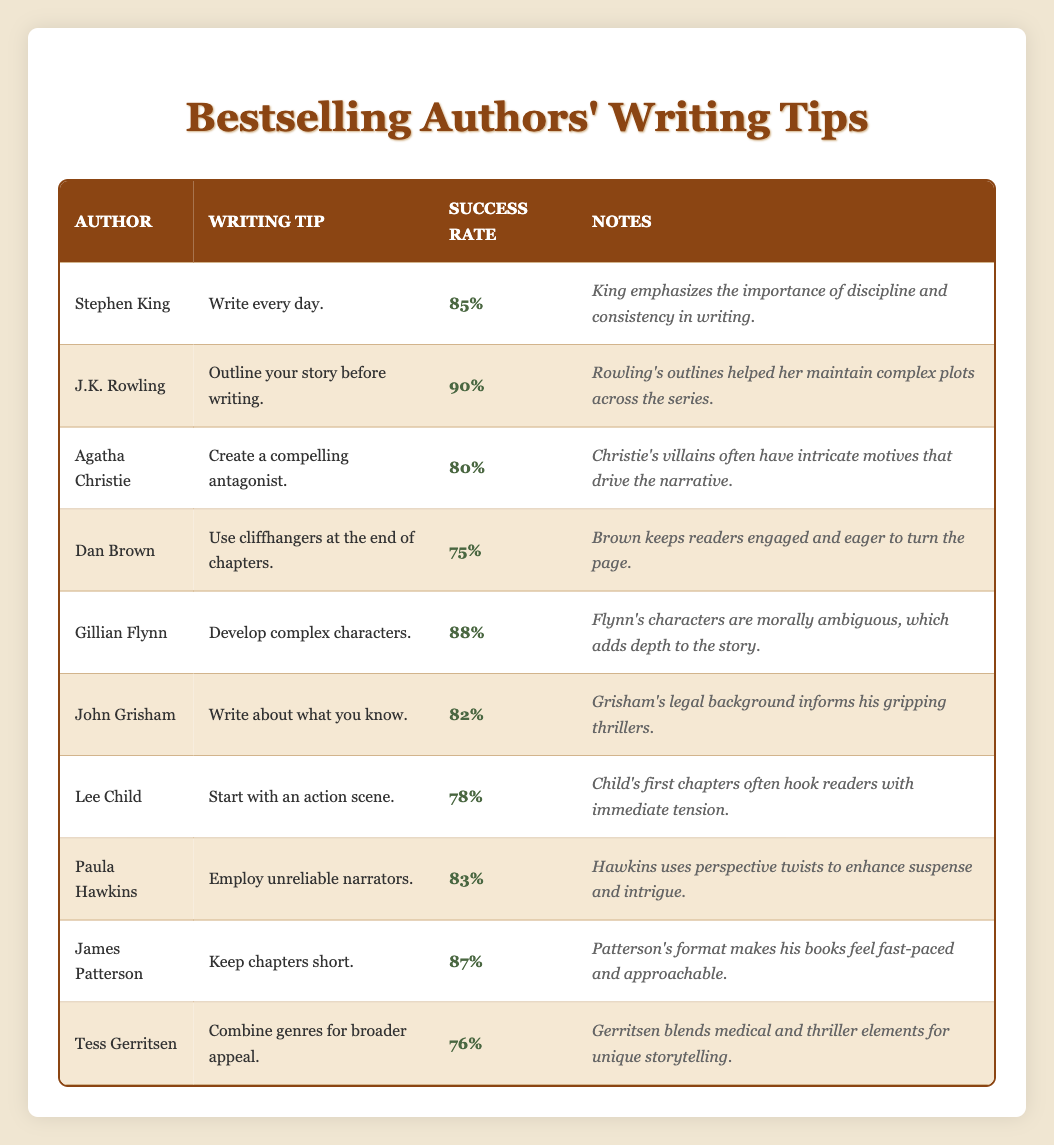What is the writing tip given by J.K. Rowling? J.K. Rowling's writing tip is found in the second row of the table. It states "Outline your story before writing."
Answer: Outline your story before writing Which author has the highest success rate? By checking the success rates listed, J.K. Rowling has the highest success rate at 90%.
Answer: J.K. Rowling What percentage of authors suggest using cliffhangers at the end of chapters? The table shows that Dan Brown suggests using cliffhangers, and his success rate is 75%.
Answer: 75% Is it true that Gillian Flynn recommends developing complex characters? The table lists Gillian Flynn's writing tip as "Develop complex characters," confirming the fact.
Answer: Yes What is the average success rate of authors recommending to write every day, outline a story, or develop complex characters? The authors recommending these tips are Stephen King, J.K. Rowling, and Gillian Flynn with success rates of 85%, 90%, and 88% respectively. The average is calculated as (85 + 90 + 88) / 3 = 87.67%.
Answer: 87.67% How many authors suggest using unreliable narrators? The table shows that only one author, Paula Hawkins, suggests using unreliable narrators.
Answer: One author What is the total success rate of authors who combine genres for broader appeal? Since only Tess Gerritsen suggests this tip, her success rate of 76% is the total for that category.
Answer: 76% Which author's approach involves keeping chapters short? The data shows that James Patterson recommends keeping chapters short, as indicated in his entry.
Answer: James Patterson Which writing tip is associated with the lowest success rate? Looking at the table, Dan Brown's tip of using cliffhangers has the lowest success rate of 75%.
Answer: Use cliffhangers at the end of chapters What are the success rates of authors who write about what they know compared to those who create compelling antagonists? John Grisham, who writes about what he knows, has a success rate of 82%, and Agatha Christie, who creates compelling antagonists, has a success rate of 80%. Therefore, Grisham's rate is higher by 2%.
Answer: John Grisham: 82%, Agatha Christie: 80% 